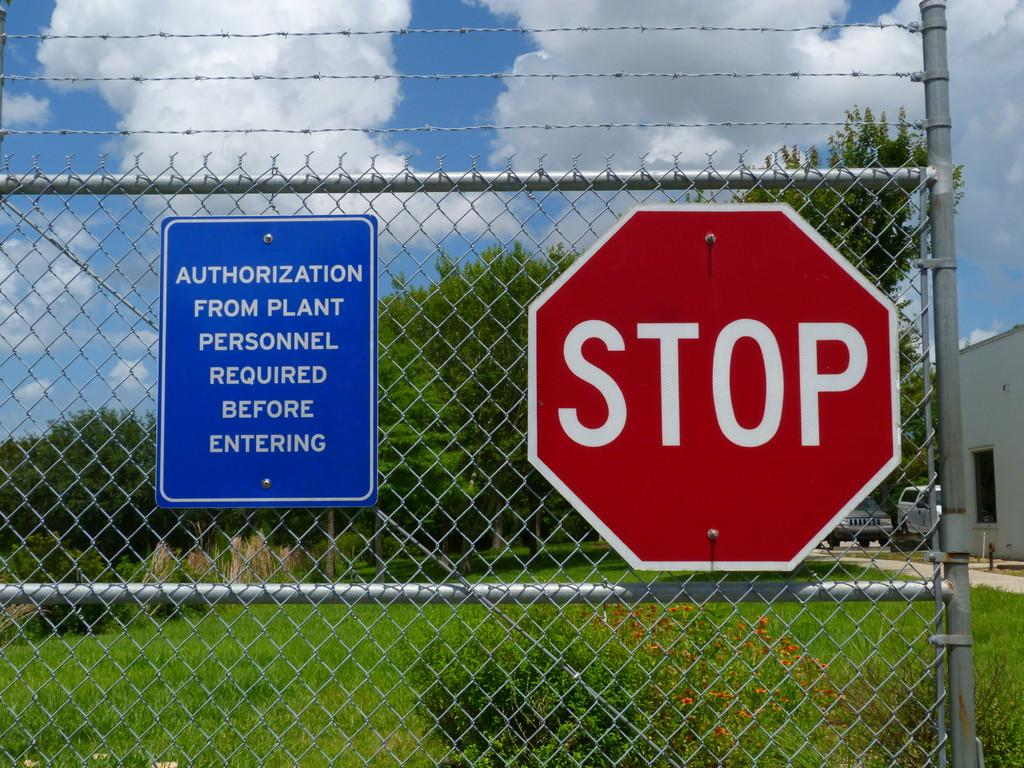Provide a one-sentence caption for the provided image. A gate that states that one must get authorization before entering. 